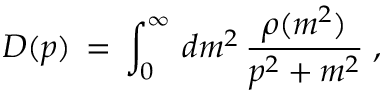<formula> <loc_0><loc_0><loc_500><loc_500>D ( p ) \, = \, \int _ { 0 } ^ { \infty } \, d m ^ { 2 } \, \frac { \rho ( m ^ { 2 } ) } { p ^ { 2 } + m ^ { 2 } } \, ,</formula> 